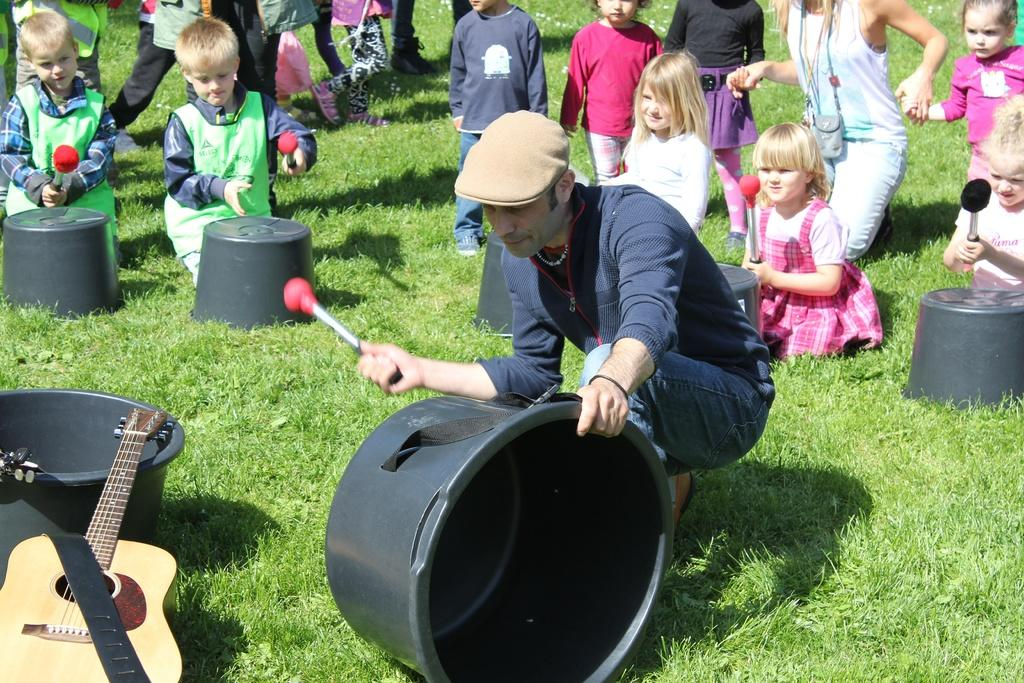What is the setting of the image? The people are sitting and standing on grass. What are the people doing in the image? They are sitting and standing. What objects can be seen in the image besides the people? There are tubs with an orange color and a guitar on the left side of the image. What type of honey can be seen dripping from the guitar in the image? There is no honey present in the image, and the guitar is not depicted as dripping anything. 